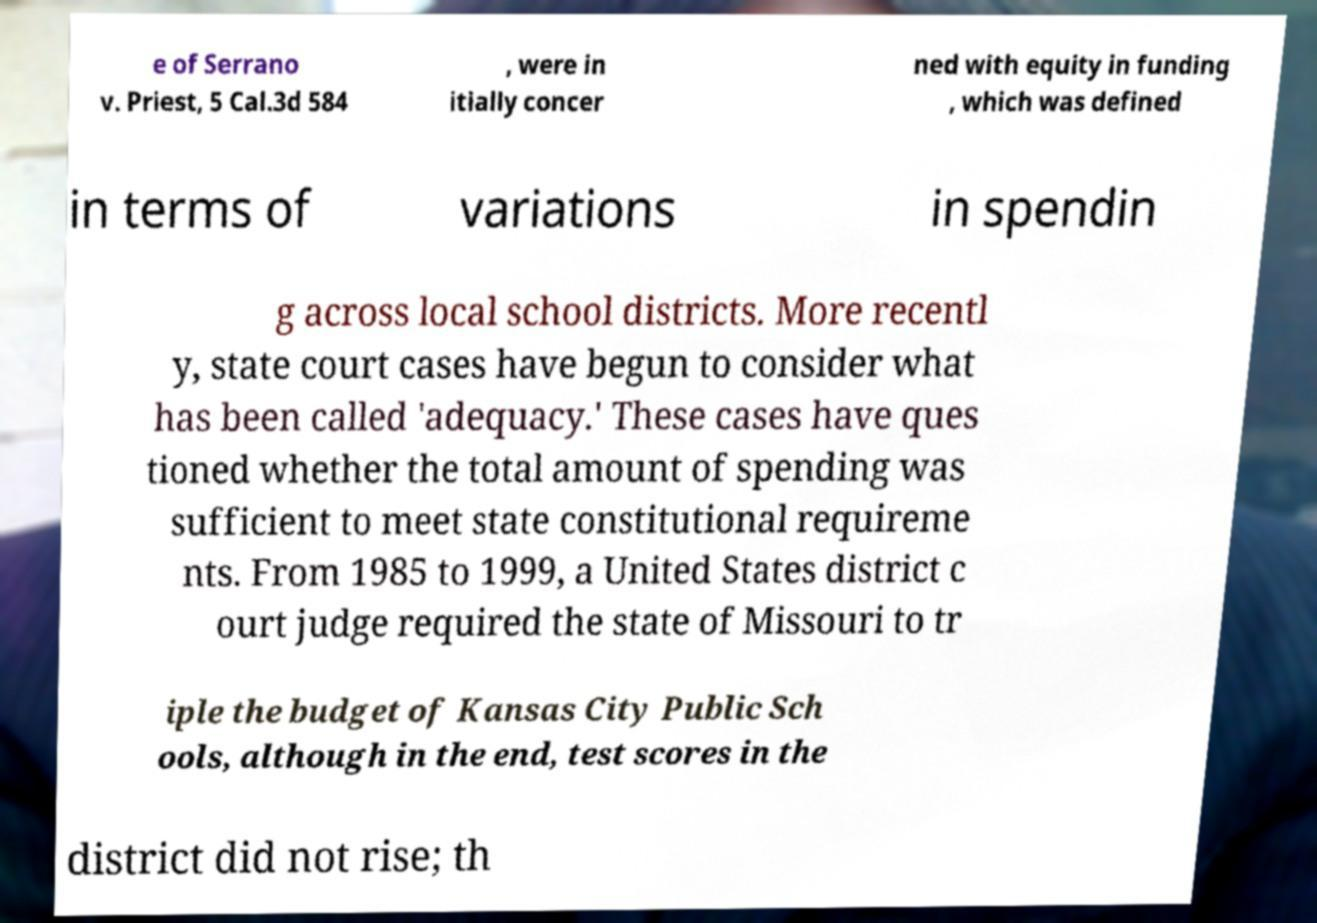Could you extract and type out the text from this image? e of Serrano v. Priest, 5 Cal.3d 584 , were in itially concer ned with equity in funding , which was defined in terms of variations in spendin g across local school districts. More recentl y, state court cases have begun to consider what has been called 'adequacy.' These cases have ques tioned whether the total amount of spending was sufficient to meet state constitutional requireme nts. From 1985 to 1999, a United States district c ourt judge required the state of Missouri to tr iple the budget of Kansas City Public Sch ools, although in the end, test scores in the district did not rise; th 